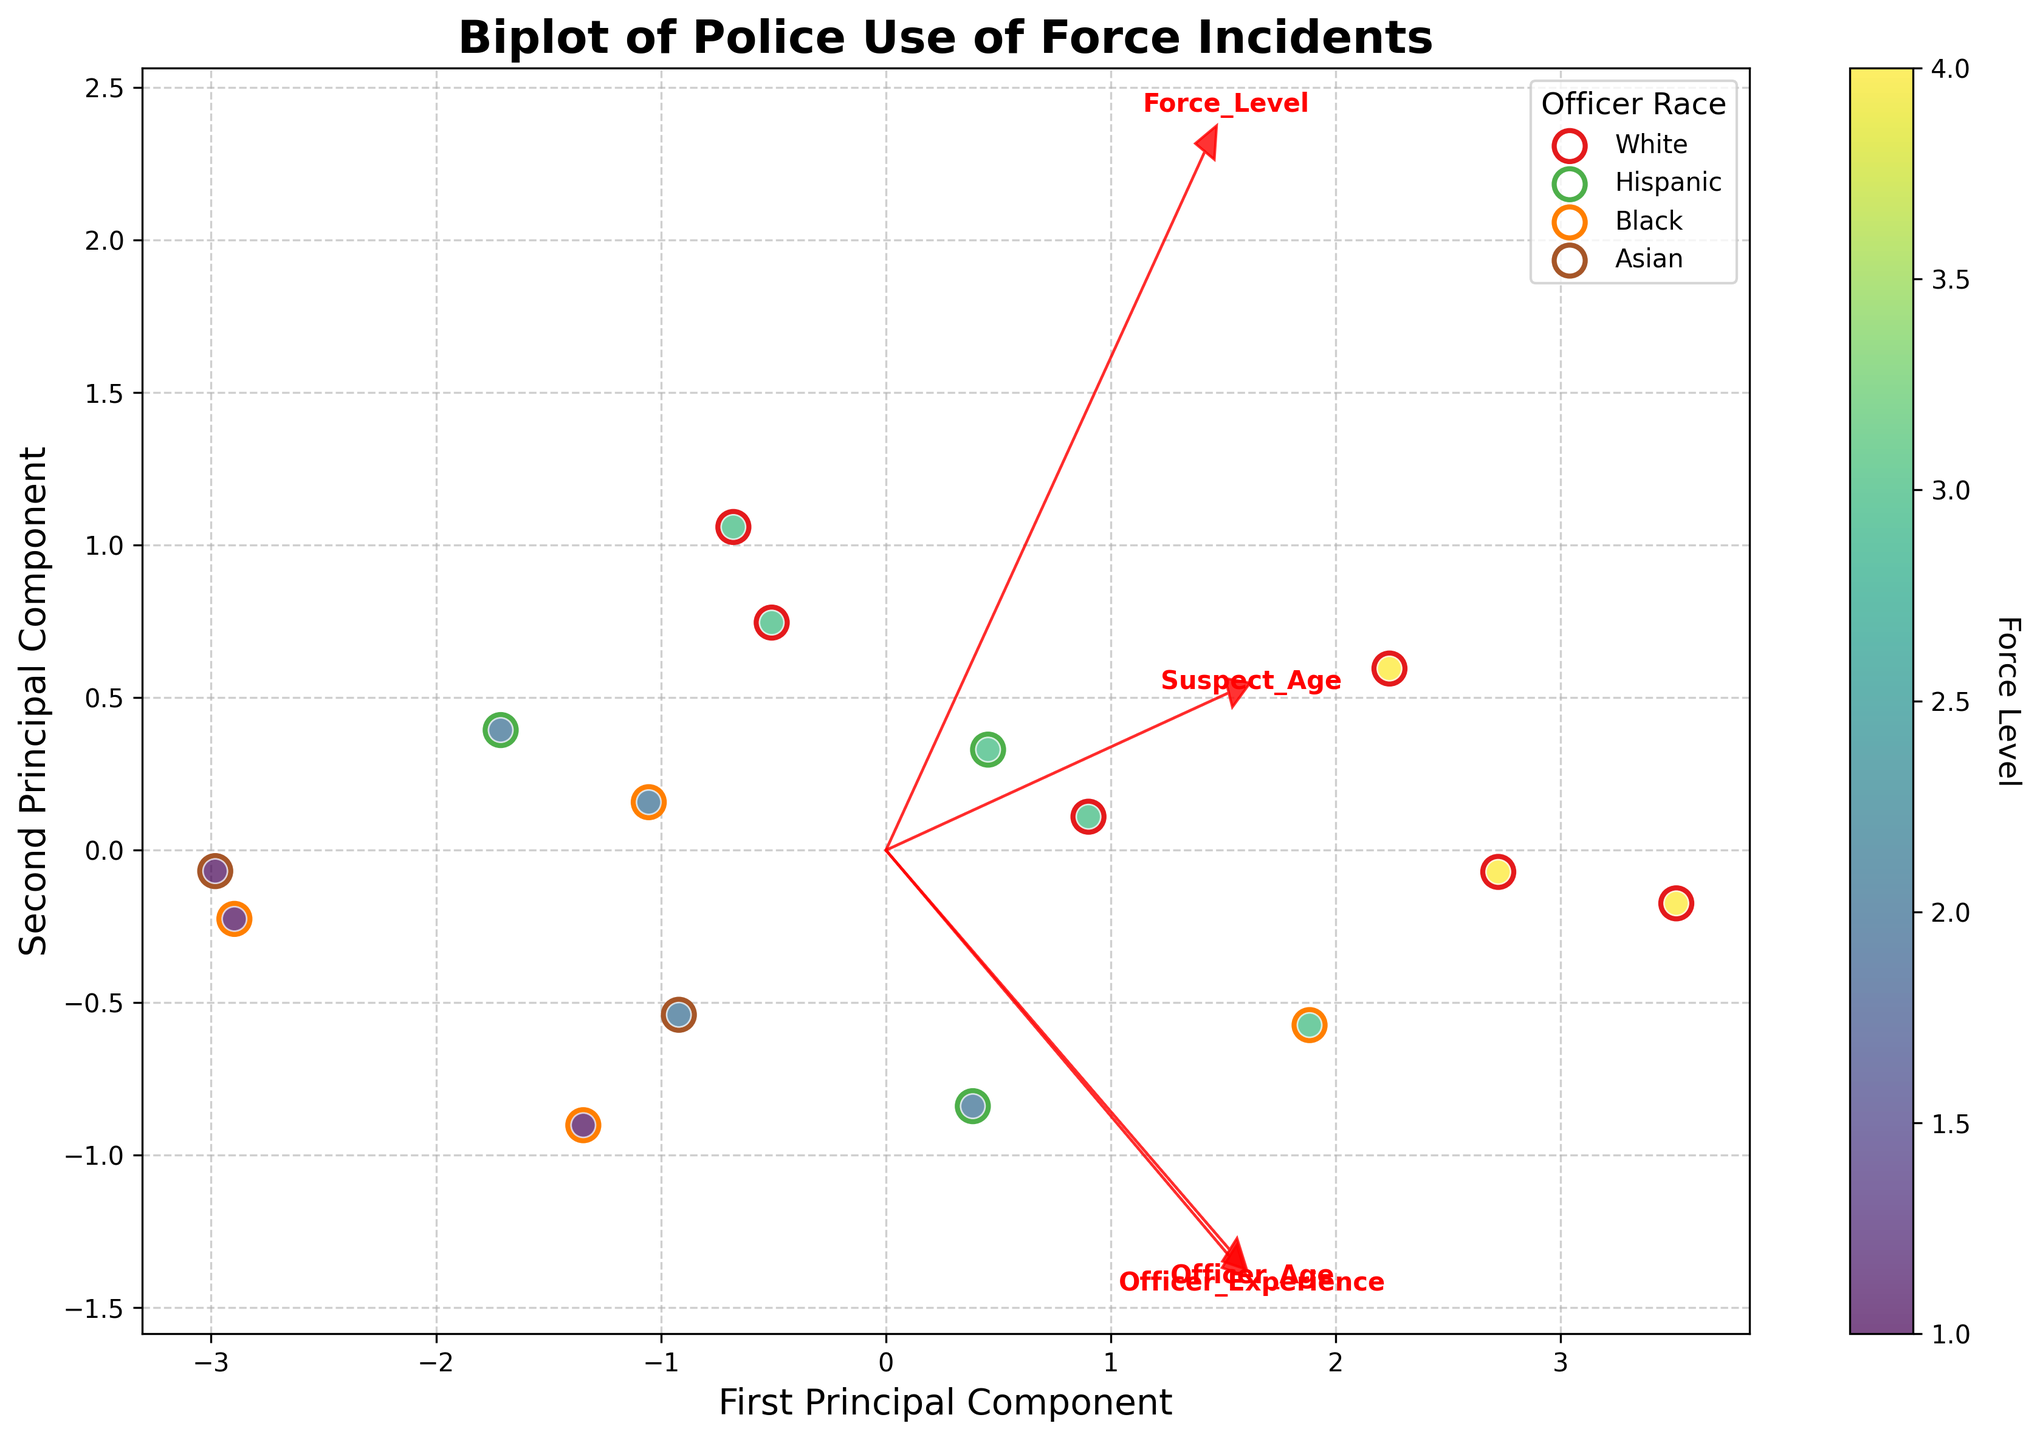How many principal components are displayed in the biplot? The biplot shows two principal components, as indicated by the labels on both axes, "First Principal Component" and "Second Principal Component".
Answer: Two What does the color gradient represent in the biplot? The color gradient represents the 'Force Level' of the incidents, as indicated by the colorbar on the right side of the plot with the label 'Force Level'.
Answer: Force Level Which variable has the longest arrow in the biplot? The variable with the longest arrow in the biplot is the one whose vector components extend furthest from the origin. From the visual inspection, 'Force_Level' appears to have the longest arrow.
Answer: Force_Level What is the purpose of the arrows in the biplot? The arrows in the biplot represent the contribution of each variable to the principal components, showing the direction and magnitude of their influence. Longer arrows indicate stronger contributions and directions indicate the nature of the relationship.
Answer: Contribution of variables Which principal component is more influenced by 'Officer_Age'? By comparing the directions and lengths of the arrows, 'Officer_Age' has a stronger projection on the First Principal Component than the Second Principal Component, as its arrow points more prominently in that direction.
Answer: First Principal Component Are there more incidents involving White officers or Black officers according to the plot? By looking at the colored legend for 'Officer Race', there are more dots with the color corresponding to "White" officers compared to "Black" officers.
Answer: More White officers Which variables are positively correlated with each other? Variables whose arrows point in similar directions have positive correlations. In this biplot, 'Officer_Age' and 'Officer_Experience' arrows point in similar directions, indicating a positive correlation.
Answer: Officer_Age and Officer_Experience Do suspects of different races show any distinctive clustering in the biplot? By observing the positions of the data points and comparing their colors, there does not appear to be a striking visual pattern or clustering based solely on suspect race in the biplot.
Answer: No distinctive clustering Is there any variable that is negatively correlated with 'Officer_Experience'? Variables with arrows pointing in opposite directions are negatively correlated. In this biplot, the arrow of 'Suspect_Age' points in nearly the opposite direction of 'Officer_Experience', indicating a negative correlation.
Answer: Suspect_Age What can be inferred about the relationship between 'Suspect_Age' and the Force Level based on the biplot? To infer this relationship, observe the direction and length of arrows of 'Suspect_Age' and 'Force_Level'. Since they point in different directions, this implies a weak or negative relationship where higher 'Suspect_Age' does not lead to higher 'Force_Level'.
Answer: Weak or negative relationship 